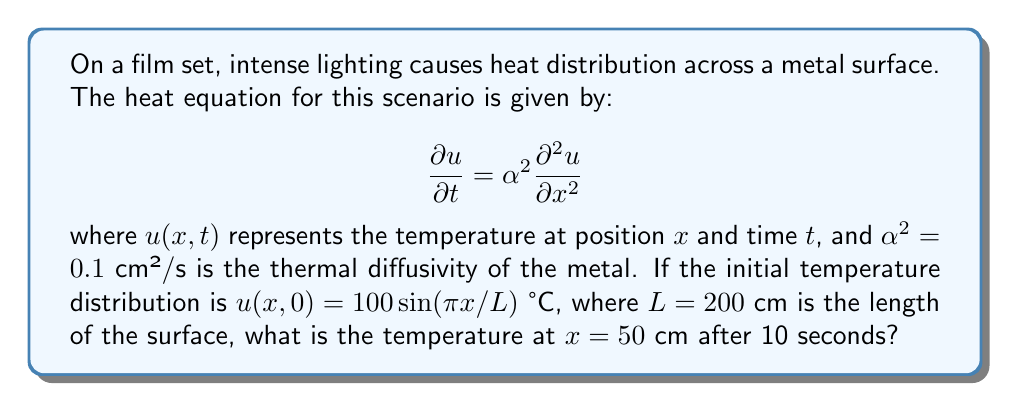Could you help me with this problem? To solve this problem, we'll use the separation of variables method for the heat equation:

1) The general solution for the heat equation with the given initial condition is:

   $$u(x,t) = \sum_{n=1}^{\infty} B_n \sin(\frac{n\pi x}{L})e^{-\alpha^2(\frac{n\pi}{L})^2t}$$

2) In our case, we only have one term in the initial condition, so $n = 1$ and $B_1 = 100$:

   $$u(x,t) = 100 \sin(\frac{\pi x}{L})e^{-\alpha^2(\frac{\pi}{L})^2t}$$

3) We're given:
   $\alpha^2 = 0.1$ cm²/s
   $L = 200$ cm
   $x = 50$ cm
   $t = 10$ s

4) Let's substitute these values:

   $$u(50,10) = 100 \sin(\frac{\pi \cdot 50}{200})e^{-0.1(\frac{\pi}{200})^2 \cdot 10}$$

5) Simplify:
   
   $$u(50,10) = 100 \sin(\frac{\pi}{4})e^{-0.1(\frac{\pi}{200})^2 \cdot 10}$$

6) Calculate:
   $\sin(\frac{\pi}{4}) = \frac{\sqrt{2}}{2} \approx 0.7071$
   $e^{-0.1(\frac{\pi}{200})^2 \cdot 10} \approx 0.9961$

7) Final calculation:

   $$u(50,10) = 100 \cdot 0.7071 \cdot 0.9961 \approx 70.42 \text{ °C}$$
Answer: 70.42 °C 